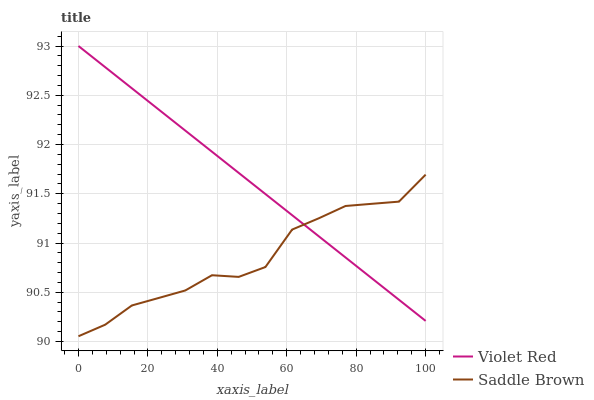Does Saddle Brown have the minimum area under the curve?
Answer yes or no. Yes. Does Violet Red have the maximum area under the curve?
Answer yes or no. Yes. Does Saddle Brown have the maximum area under the curve?
Answer yes or no. No. Is Violet Red the smoothest?
Answer yes or no. Yes. Is Saddle Brown the roughest?
Answer yes or no. Yes. Is Saddle Brown the smoothest?
Answer yes or no. No. Does Saddle Brown have the lowest value?
Answer yes or no. Yes. Does Violet Red have the highest value?
Answer yes or no. Yes. Does Saddle Brown have the highest value?
Answer yes or no. No. Does Violet Red intersect Saddle Brown?
Answer yes or no. Yes. Is Violet Red less than Saddle Brown?
Answer yes or no. No. Is Violet Red greater than Saddle Brown?
Answer yes or no. No. 